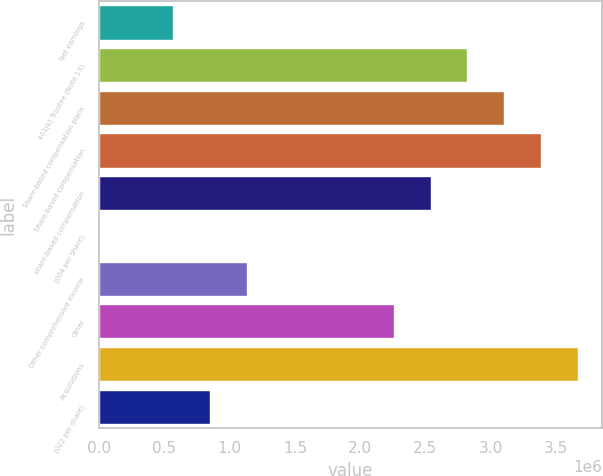Convert chart. <chart><loc_0><loc_0><loc_500><loc_500><bar_chart><fcel>Net earnings<fcel>401(k) Trustee (Note 13)<fcel>Share-based compensation plans<fcel>Share-based compensation<fcel>share-based compensation<fcel>(004 per share)<fcel>Other comprehensive income<fcel>Other<fcel>Acquisitions<fcel>(022 per share)<nl><fcel>564516<fcel>2.82258e+06<fcel>3.10484e+06<fcel>3.38709e+06<fcel>2.54032e+06<fcel>0.11<fcel>1.12903e+06<fcel>2.25806e+06<fcel>3.66935e+06<fcel>846773<nl></chart> 